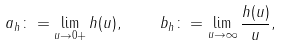<formula> <loc_0><loc_0><loc_500><loc_500>a _ { h } \colon = \lim _ { u \to 0 + } h ( u ) , \quad b _ { h } \colon = \lim _ { u \to \infty } \frac { h ( u ) } { u } ,</formula> 